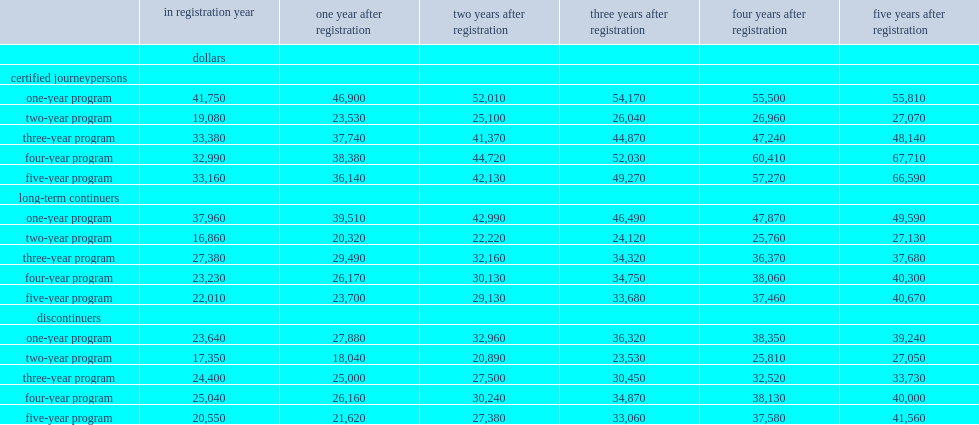List all the employee types. Certified journeypersons long-term continuers discontinuers. How much does the income gaps between certified journeypersons and long-term continuers reach five years after registration for those registered in four-year programs? 27410. How much does the income gaps between certified journeypersons and discontinuers reach five years after registration for those registered in four-year programs? 27710. How much does the income gaps between certified journeypersons and long-term continuers reach five years after registration for those registered in five-year programs? 25920. How much does the income gaps between certified journeypersons and discontinuers reach five years after registration for those registered in five-year programs? 25030. 